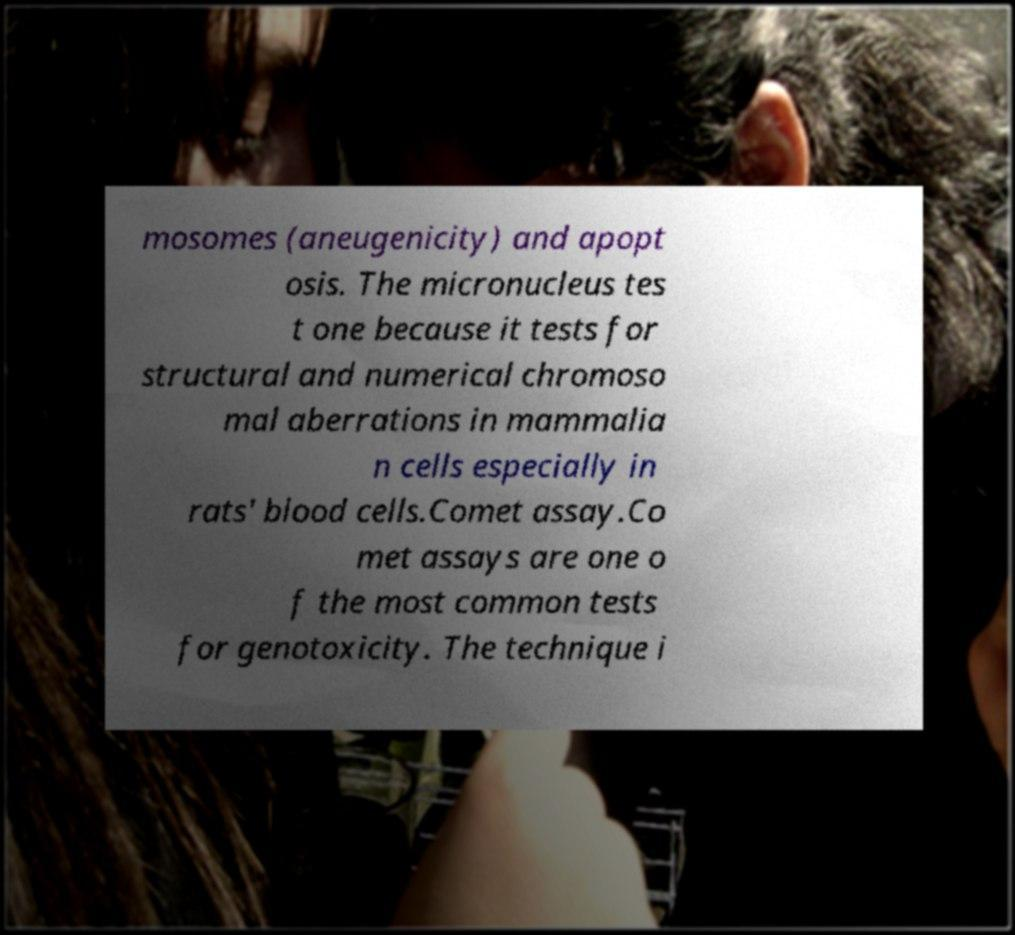Can you read and provide the text displayed in the image?This photo seems to have some interesting text. Can you extract and type it out for me? mosomes (aneugenicity) and apopt osis. The micronucleus tes t one because it tests for structural and numerical chromoso mal aberrations in mammalia n cells especially in rats' blood cells.Comet assay.Co met assays are one o f the most common tests for genotoxicity. The technique i 